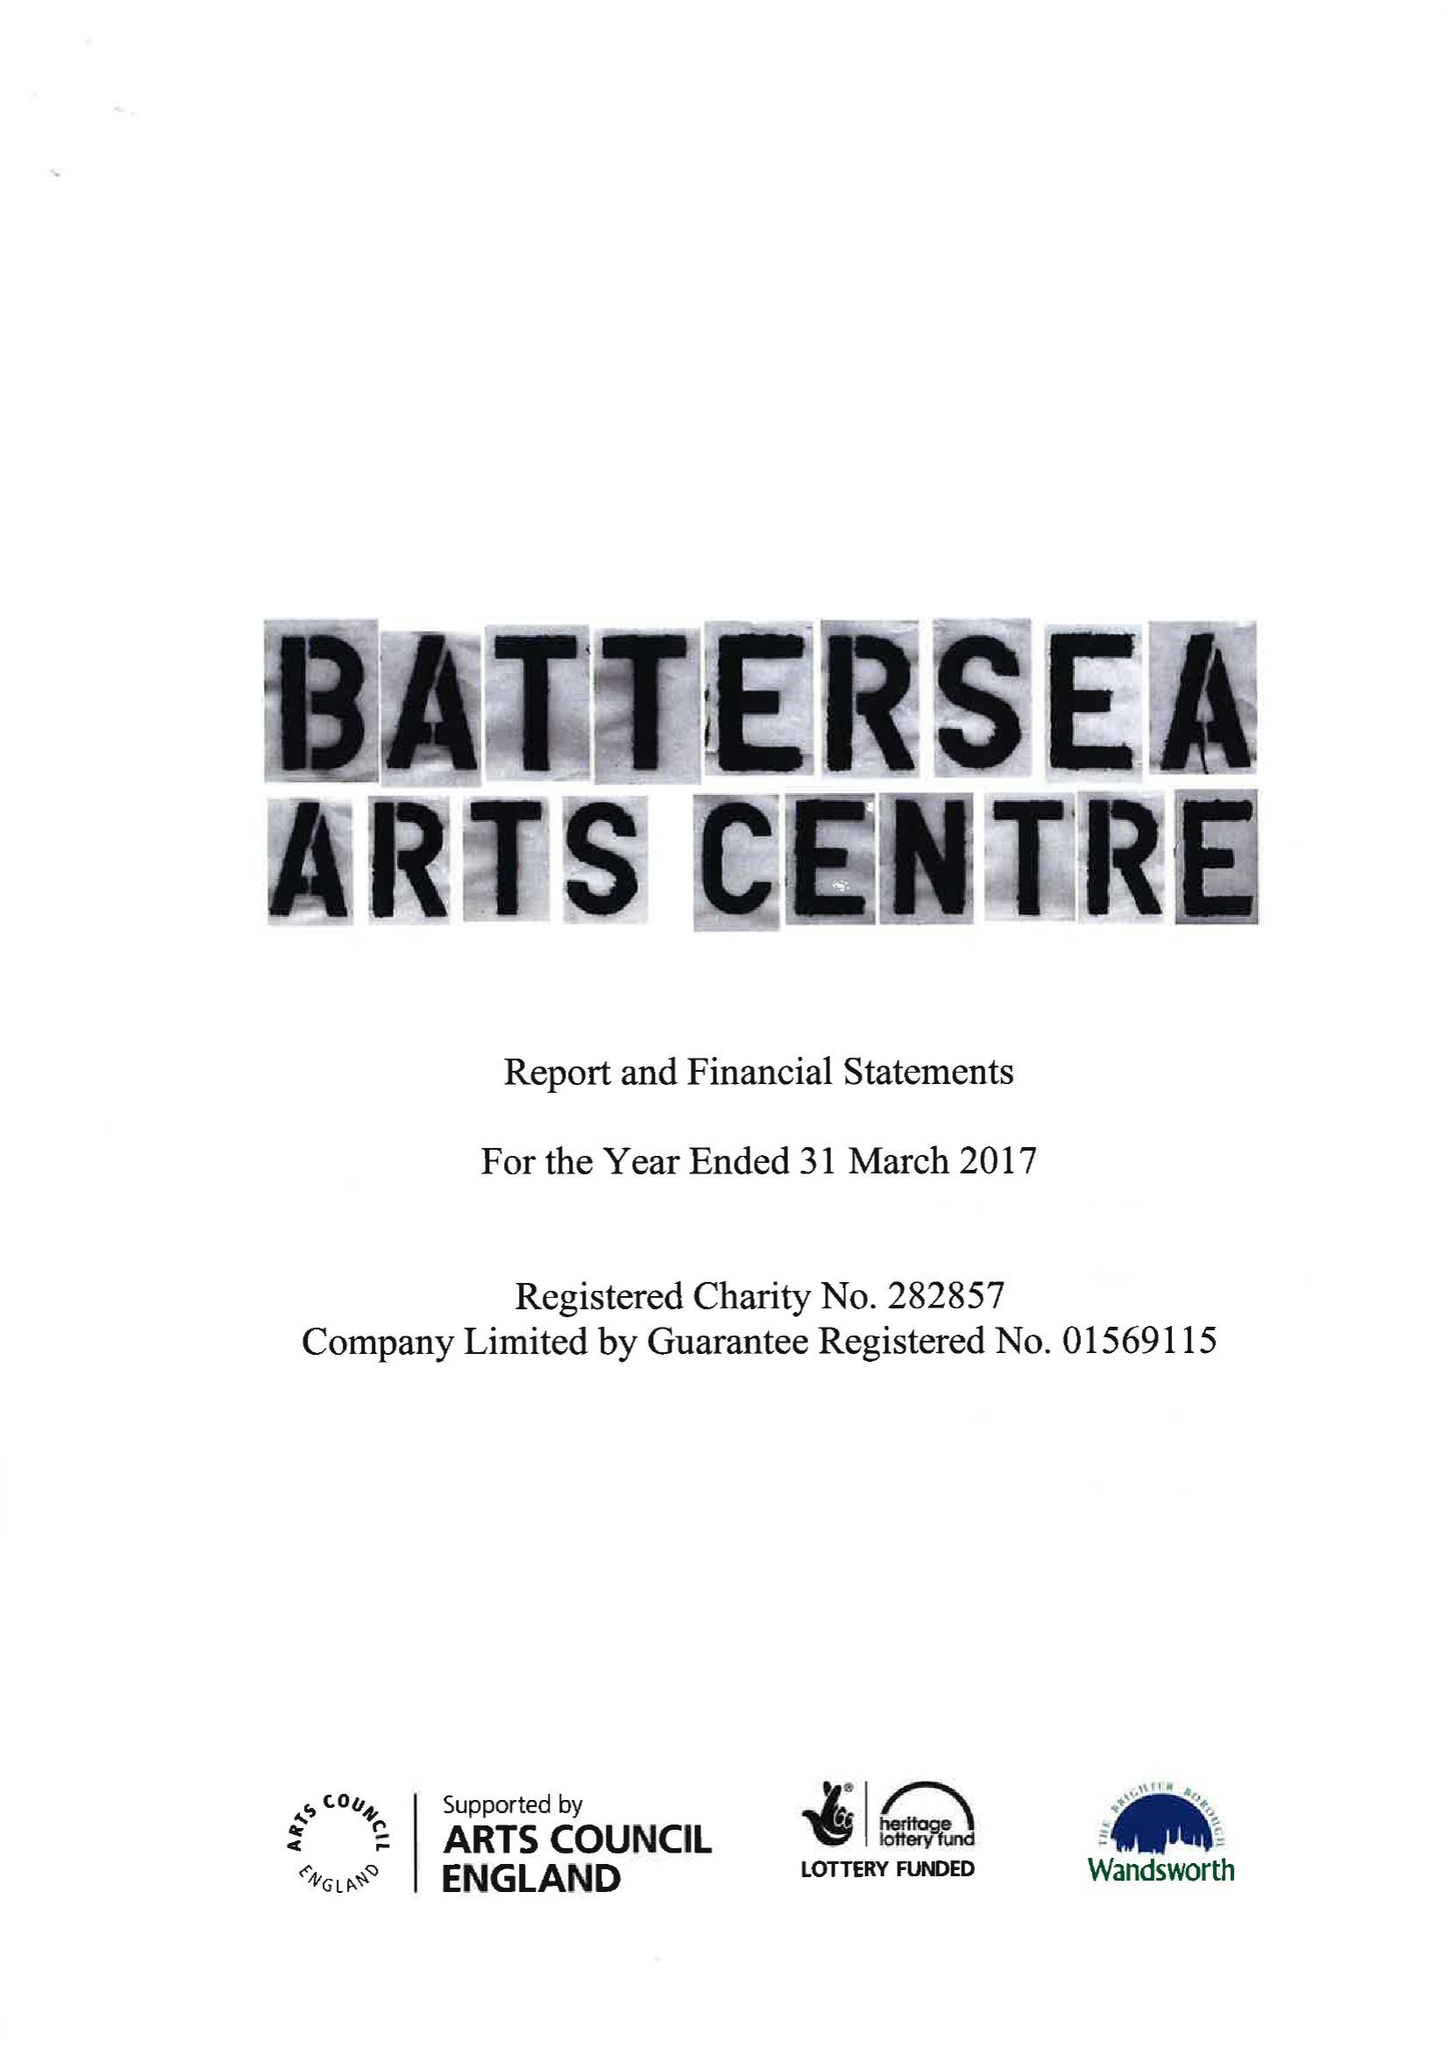What is the value for the charity_number?
Answer the question using a single word or phrase. 282857 